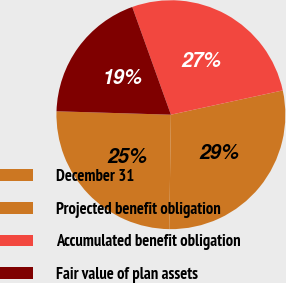<chart> <loc_0><loc_0><loc_500><loc_500><pie_chart><fcel>December 31<fcel>Projected benefit obligation<fcel>Accumulated benefit obligation<fcel>Fair value of plan assets<nl><fcel>25.25%<fcel>28.63%<fcel>27.08%<fcel>19.04%<nl></chart> 